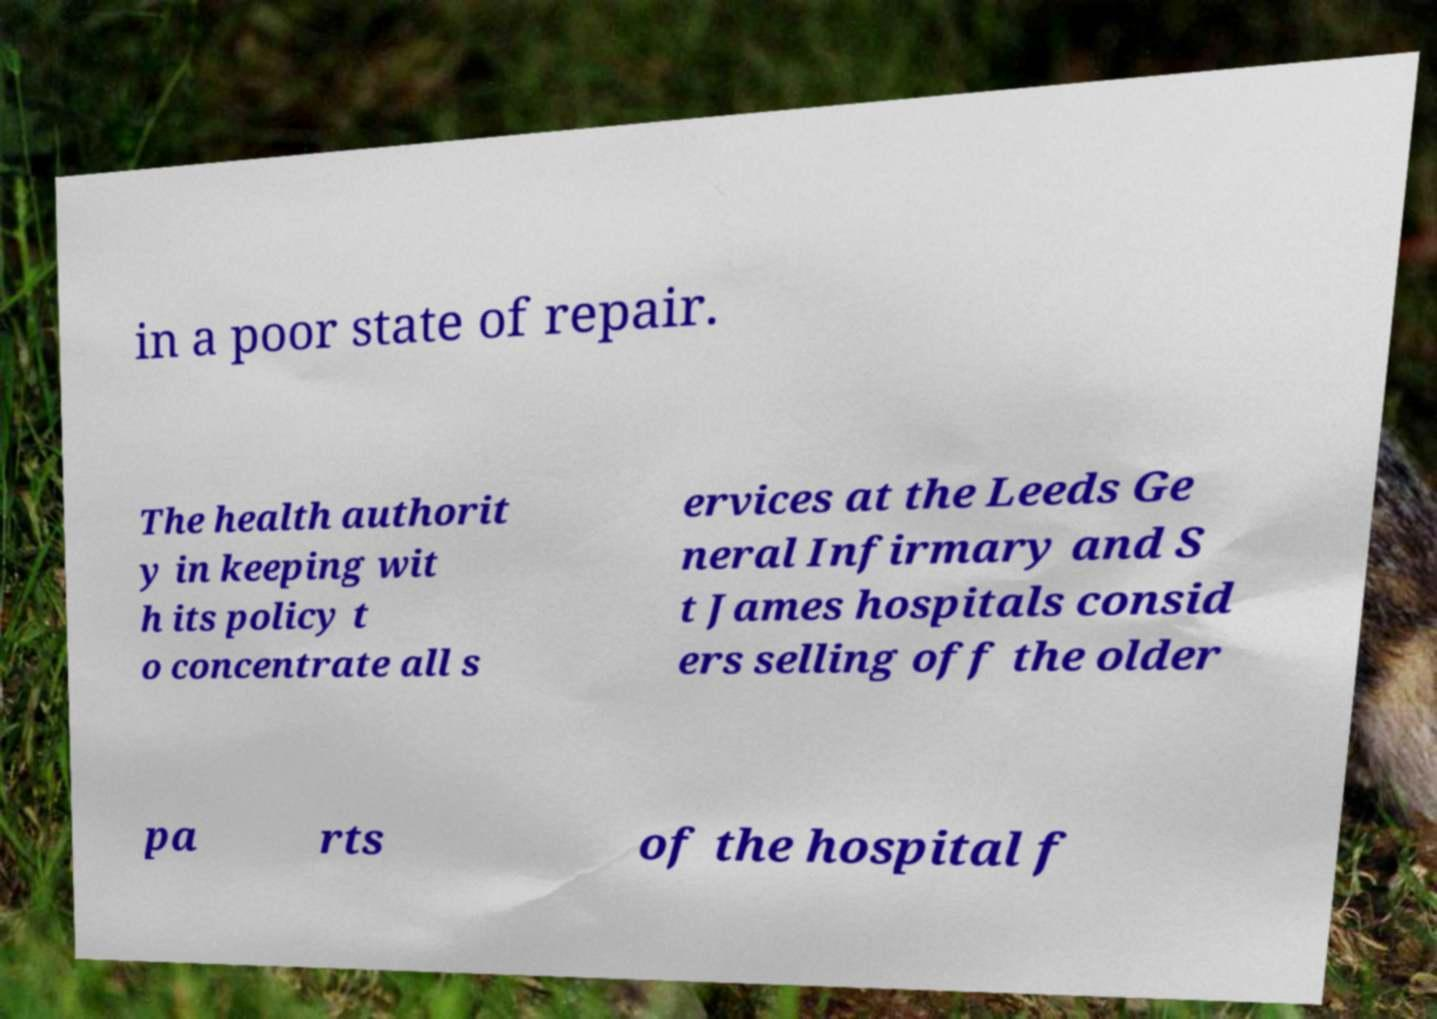For documentation purposes, I need the text within this image transcribed. Could you provide that? in a poor state of repair. The health authorit y in keeping wit h its policy t o concentrate all s ervices at the Leeds Ge neral Infirmary and S t James hospitals consid ers selling off the older pa rts of the hospital f 